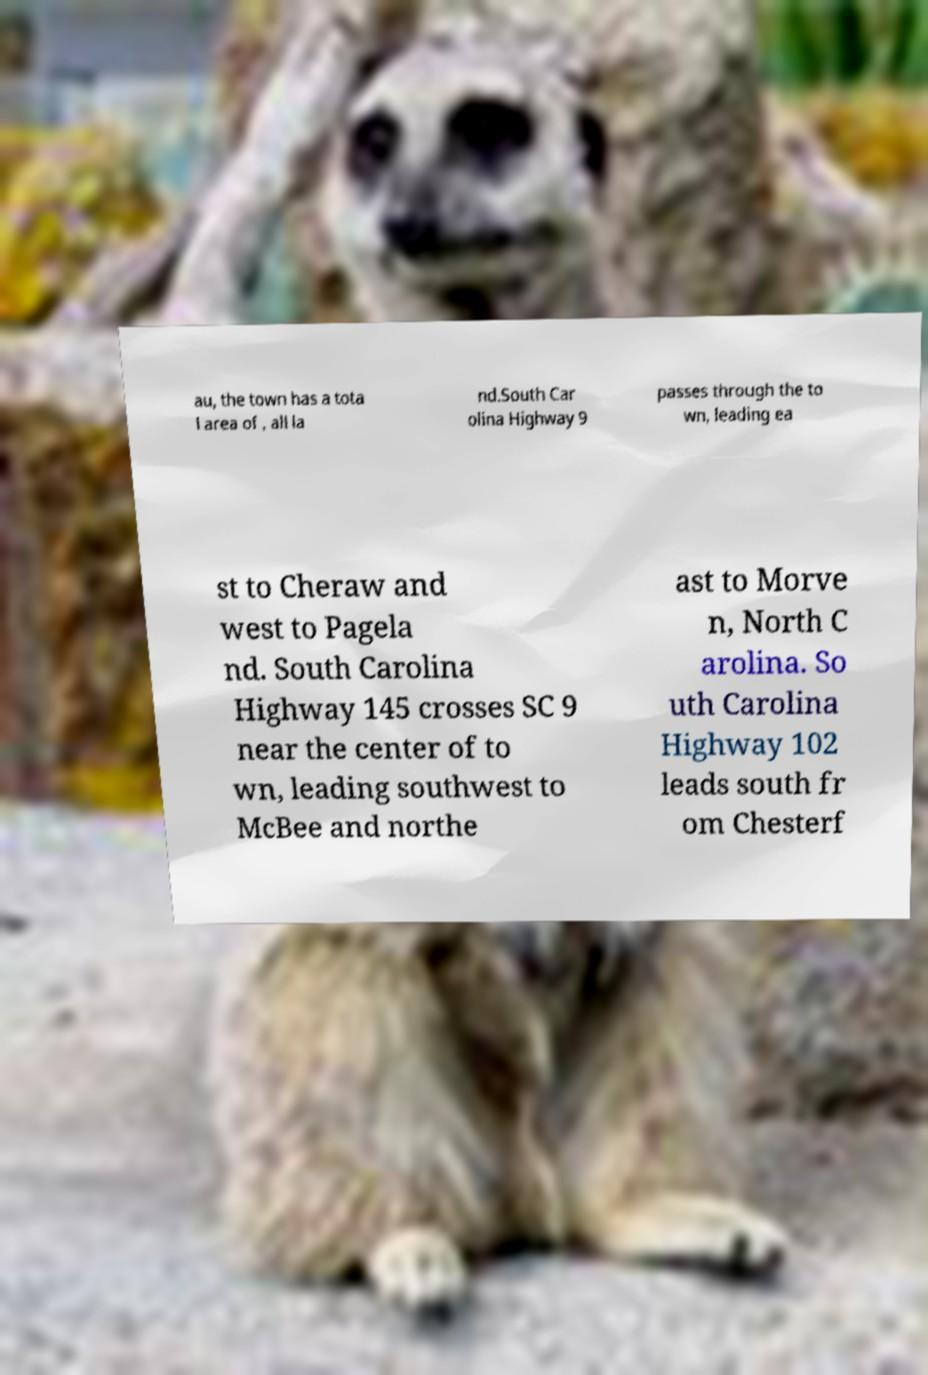Can you accurately transcribe the text from the provided image for me? au, the town has a tota l area of , all la nd.South Car olina Highway 9 passes through the to wn, leading ea st to Cheraw and west to Pagela nd. South Carolina Highway 145 crosses SC 9 near the center of to wn, leading southwest to McBee and northe ast to Morve n, North C arolina. So uth Carolina Highway 102 leads south fr om Chesterf 